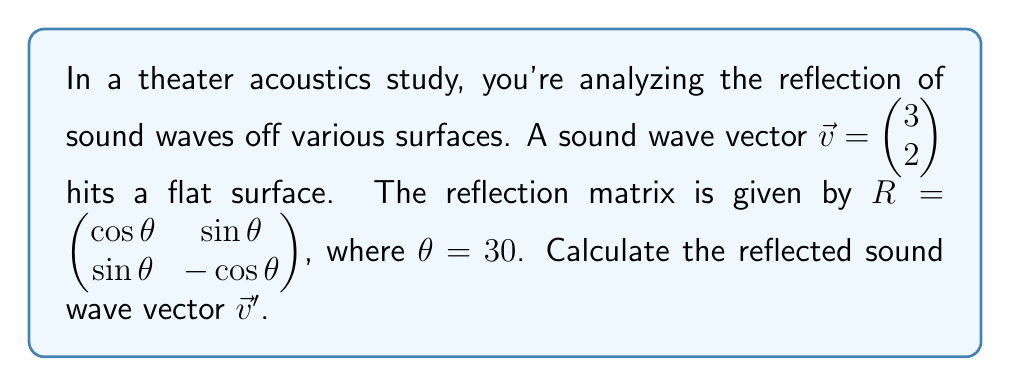Could you help me with this problem? To solve this problem, we'll follow these steps:

1. Convert the angle to radians:
   $\theta = 30° = \frac{\pi}{6}$ radians

2. Calculate the values for $\cos \theta$ and $\sin \theta$:
   $\cos \frac{\pi}{6} = \frac{\sqrt{3}}{2}$
   $\sin \frac{\pi}{6} = \frac{1}{2}$

3. Construct the reflection matrix $R$:
   $$R = \begin{pmatrix} \frac{\sqrt{3}}{2} & \frac{1}{2} \\ \frac{1}{2} & -\frac{\sqrt{3}}{2} \end{pmatrix}$$

4. Perform the matrix multiplication $R\vec{v}$:
   $$\vec{v}' = R\vec{v} = \begin{pmatrix} \frac{\sqrt{3}}{2} & \frac{1}{2} \\ \frac{1}{2} & -\frac{\sqrt{3}}{2} \end{pmatrix} \begin{pmatrix} 3 \\ 2 \end{pmatrix}$$

5. Calculate the components of $\vec{v}'$:
   $v'_x = \frac{\sqrt{3}}{2}(3) + \frac{1}{2}(2) = \frac{3\sqrt{3}}{2} + 1$
   $v'_y = \frac{1}{2}(3) - \frac{\sqrt{3}}{2}(2) = \frac{3}{2} - \sqrt{3}$

6. Simplify the result:
   $$\vec{v}' = \begin{pmatrix} \frac{3\sqrt{3}}{2} + 1 \\ \frac{3}{2} - \sqrt{3} \end{pmatrix}$$

This linear transformation represents how the sound wave is reflected off the surface, which is crucial for understanding the acoustic properties of the theater.
Answer: $$\vec{v}' = \begin{pmatrix} \frac{3\sqrt{3}}{2} + 1 \\ \frac{3}{2} - \sqrt{3} \end{pmatrix}$$ 